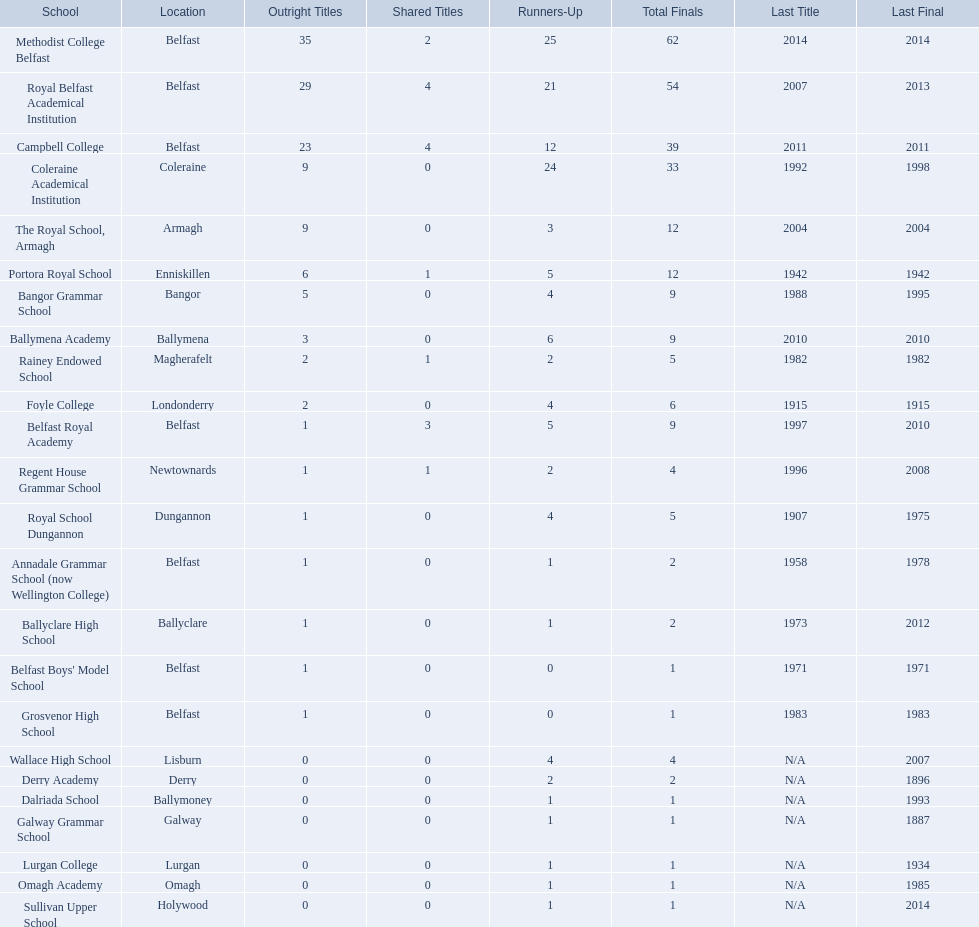Which colleges participated in the ulster's schools' cup? Methodist College Belfast, Royal Belfast Academical Institution, Campbell College, Coleraine Academical Institution, The Royal School, Armagh, Portora Royal School, Bangor Grammar School, Ballymena Academy, Rainey Endowed School, Foyle College, Belfast Royal Academy, Regent House Grammar School, Royal School Dungannon, Annadale Grammar School (now Wellington College), Ballyclare High School, Belfast Boys' Model School, Grosvenor High School, Wallace High School, Derry Academy, Dalriada School, Galway Grammar School, Lurgan College, Omagh Academy, Sullivan Upper School. Of these, which are from belfast? Methodist College Belfast, Royal Belfast Academical Institution, Campbell College, Belfast Royal Academy, Annadale Grammar School (now Wellington College), Belfast Boys' Model School, Grosvenor High School. Of these, which have more than 20 outright titles? Methodist College Belfast, Royal Belfast Academical Institution, Campbell College. Which of these have the fewest runners-up? Campbell College. Can you list all the school names? Methodist College Belfast, Royal Belfast Academical Institution, Campbell College, Coleraine Academical Institution, The Royal School, Armagh, Portora Royal School, Bangor Grammar School, Ballymena Academy, Rainey Endowed School, Foyle College, Belfast Royal Academy, Regent House Grammar School, Royal School Dungannon, Annadale Grammar School (now Wellington College), Ballyclare High School, Belfast Boys' Model School, Grosvenor High School, Wallace High School, Derry Academy, Dalriada School, Galway Grammar School, Lurgan College, Omagh Academy, Sullivan Upper School. What is the total number of outright titles they won? 35, 29, 23, 9, 9, 6, 5, 3, 2, 2, 1, 1, 1, 1, 1, 1, 1, 0, 0, 0, 0, 0, 0, 0. How many outright titles were awarded to coleraine academical institution? 9. Is there another school with the same amount of outright titles? The Royal School, Armagh. 